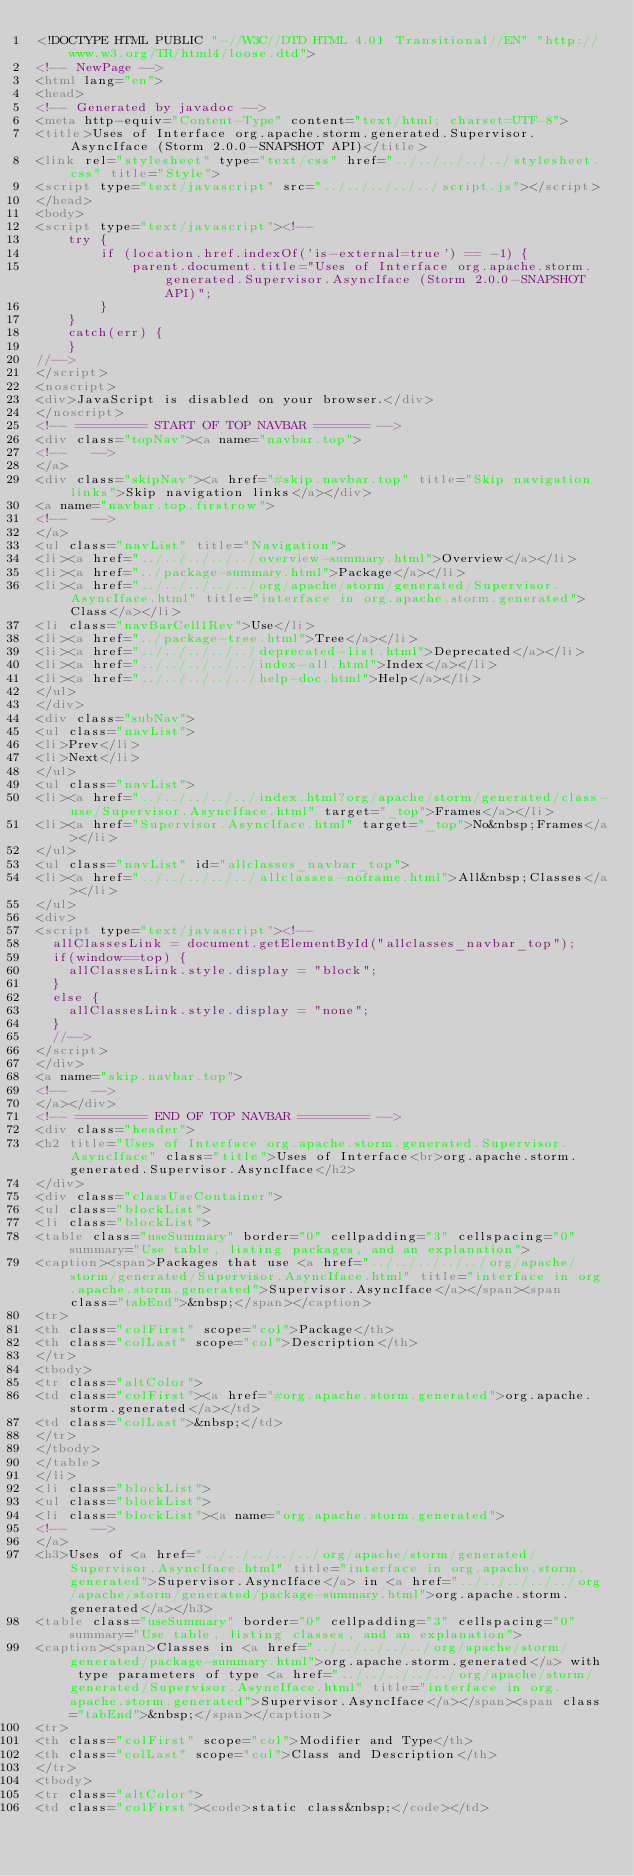Convert code to text. <code><loc_0><loc_0><loc_500><loc_500><_HTML_><!DOCTYPE HTML PUBLIC "-//W3C//DTD HTML 4.01 Transitional//EN" "http://www.w3.org/TR/html4/loose.dtd">
<!-- NewPage -->
<html lang="en">
<head>
<!-- Generated by javadoc -->
<meta http-equiv="Content-Type" content="text/html; charset=UTF-8">
<title>Uses of Interface org.apache.storm.generated.Supervisor.AsyncIface (Storm 2.0.0-SNAPSHOT API)</title>
<link rel="stylesheet" type="text/css" href="../../../../../stylesheet.css" title="Style">
<script type="text/javascript" src="../../../../../script.js"></script>
</head>
<body>
<script type="text/javascript"><!--
    try {
        if (location.href.indexOf('is-external=true') == -1) {
            parent.document.title="Uses of Interface org.apache.storm.generated.Supervisor.AsyncIface (Storm 2.0.0-SNAPSHOT API)";
        }
    }
    catch(err) {
    }
//-->
</script>
<noscript>
<div>JavaScript is disabled on your browser.</div>
</noscript>
<!-- ========= START OF TOP NAVBAR ======= -->
<div class="topNav"><a name="navbar.top">
<!--   -->
</a>
<div class="skipNav"><a href="#skip.navbar.top" title="Skip navigation links">Skip navigation links</a></div>
<a name="navbar.top.firstrow">
<!--   -->
</a>
<ul class="navList" title="Navigation">
<li><a href="../../../../../overview-summary.html">Overview</a></li>
<li><a href="../package-summary.html">Package</a></li>
<li><a href="../../../../../org/apache/storm/generated/Supervisor.AsyncIface.html" title="interface in org.apache.storm.generated">Class</a></li>
<li class="navBarCell1Rev">Use</li>
<li><a href="../package-tree.html">Tree</a></li>
<li><a href="../../../../../deprecated-list.html">Deprecated</a></li>
<li><a href="../../../../../index-all.html">Index</a></li>
<li><a href="../../../../../help-doc.html">Help</a></li>
</ul>
</div>
<div class="subNav">
<ul class="navList">
<li>Prev</li>
<li>Next</li>
</ul>
<ul class="navList">
<li><a href="../../../../../index.html?org/apache/storm/generated/class-use/Supervisor.AsyncIface.html" target="_top">Frames</a></li>
<li><a href="Supervisor.AsyncIface.html" target="_top">No&nbsp;Frames</a></li>
</ul>
<ul class="navList" id="allclasses_navbar_top">
<li><a href="../../../../../allclasses-noframe.html">All&nbsp;Classes</a></li>
</ul>
<div>
<script type="text/javascript"><!--
  allClassesLink = document.getElementById("allclasses_navbar_top");
  if(window==top) {
    allClassesLink.style.display = "block";
  }
  else {
    allClassesLink.style.display = "none";
  }
  //-->
</script>
</div>
<a name="skip.navbar.top">
<!--   -->
</a></div>
<!-- ========= END OF TOP NAVBAR ========= -->
<div class="header">
<h2 title="Uses of Interface org.apache.storm.generated.Supervisor.AsyncIface" class="title">Uses of Interface<br>org.apache.storm.generated.Supervisor.AsyncIface</h2>
</div>
<div class="classUseContainer">
<ul class="blockList">
<li class="blockList">
<table class="useSummary" border="0" cellpadding="3" cellspacing="0" summary="Use table, listing packages, and an explanation">
<caption><span>Packages that use <a href="../../../../../org/apache/storm/generated/Supervisor.AsyncIface.html" title="interface in org.apache.storm.generated">Supervisor.AsyncIface</a></span><span class="tabEnd">&nbsp;</span></caption>
<tr>
<th class="colFirst" scope="col">Package</th>
<th class="colLast" scope="col">Description</th>
</tr>
<tbody>
<tr class="altColor">
<td class="colFirst"><a href="#org.apache.storm.generated">org.apache.storm.generated</a></td>
<td class="colLast">&nbsp;</td>
</tr>
</tbody>
</table>
</li>
<li class="blockList">
<ul class="blockList">
<li class="blockList"><a name="org.apache.storm.generated">
<!--   -->
</a>
<h3>Uses of <a href="../../../../../org/apache/storm/generated/Supervisor.AsyncIface.html" title="interface in org.apache.storm.generated">Supervisor.AsyncIface</a> in <a href="../../../../../org/apache/storm/generated/package-summary.html">org.apache.storm.generated</a></h3>
<table class="useSummary" border="0" cellpadding="3" cellspacing="0" summary="Use table, listing classes, and an explanation">
<caption><span>Classes in <a href="../../../../../org/apache/storm/generated/package-summary.html">org.apache.storm.generated</a> with type parameters of type <a href="../../../../../org/apache/storm/generated/Supervisor.AsyncIface.html" title="interface in org.apache.storm.generated">Supervisor.AsyncIface</a></span><span class="tabEnd">&nbsp;</span></caption>
<tr>
<th class="colFirst" scope="col">Modifier and Type</th>
<th class="colLast" scope="col">Class and Description</th>
</tr>
<tbody>
<tr class="altColor">
<td class="colFirst"><code>static class&nbsp;</code></td></code> 